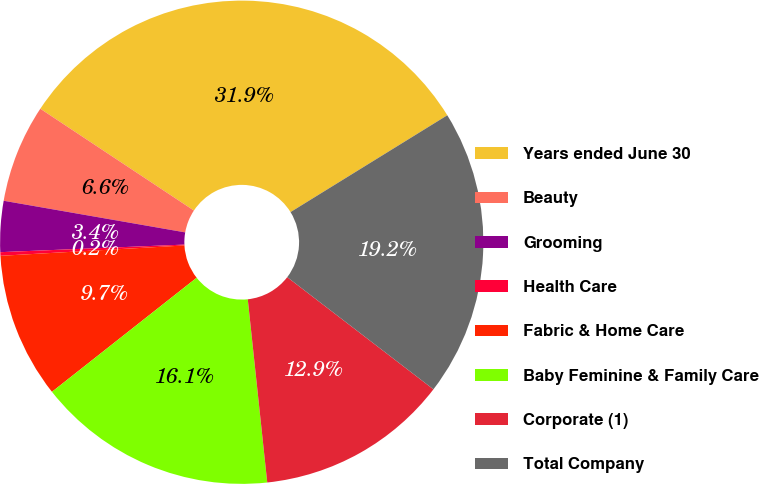Convert chart. <chart><loc_0><loc_0><loc_500><loc_500><pie_chart><fcel>Years ended June 30<fcel>Beauty<fcel>Grooming<fcel>Health Care<fcel>Fabric & Home Care<fcel>Baby Feminine & Family Care<fcel>Corporate (1)<fcel>Total Company<nl><fcel>31.88%<fcel>6.57%<fcel>3.4%<fcel>0.24%<fcel>9.73%<fcel>16.06%<fcel>12.9%<fcel>19.22%<nl></chart> 